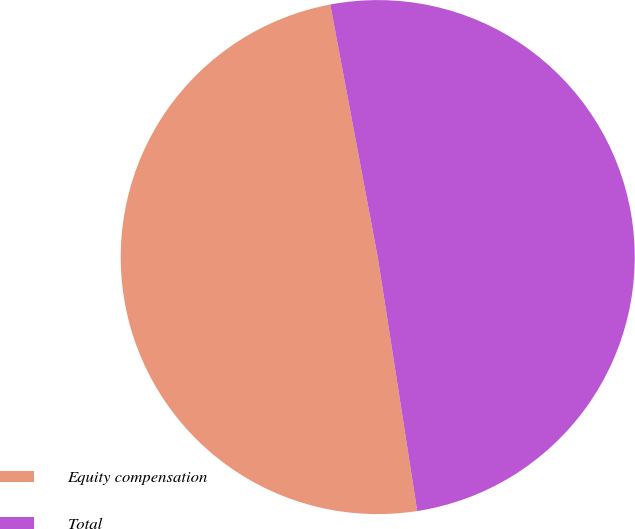Convert chart to OTSL. <chart><loc_0><loc_0><loc_500><loc_500><pie_chart><fcel>Equity compensation<fcel>Total<nl><fcel>49.5%<fcel>50.5%<nl></chart> 